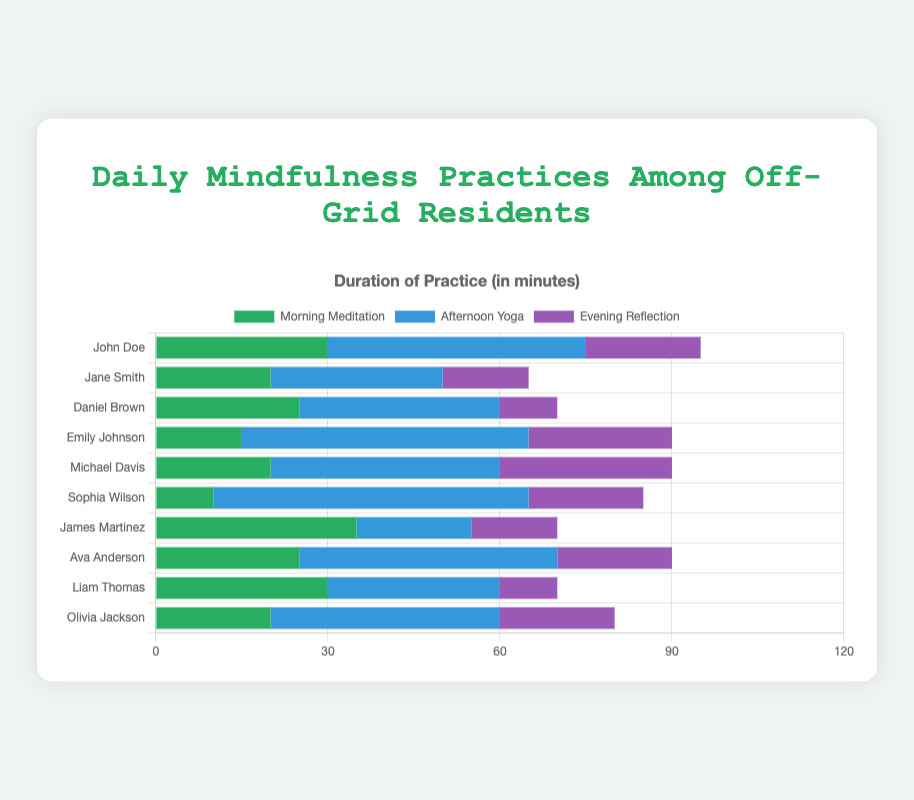Which resident spends the most time on evening reflection? Looking at the “Evening Reflection” segment for each resident, the one with the longest bar is Michael Davis, who spends 30 minutes on evening reflection.
Answer: Michael Davis What is the total duration of mindfulness practices of John Doe? Adding up the different practices for John: Morning Meditation (30 minutes) + Afternoon Yoga (45 minutes) + Evening Reflection (20 minutes) equals 95 minutes.
Answer: 95 minutes Who spends equal or more time on morning meditation than afternoon yoga? Comparing each resident's "Morning Meditation" and "Afternoon Yoga" bars: James Martinez spends equal, and John Doe, Daniel Brown, and Liam Thomas spend more time on morning meditation than on afternoon yoga.
Answer: James Martinez, John Doe, Daniel Brown, Liam Thomas How much more time does Michael Davis spend on afternoon yoga compared to his evening reflection? Michael Davis spends 40 minutes on afternoon yoga and 30 minutes on evening reflection. The difference is 40 - 30 = 10 minutes.
Answer: 10 minutes Which resident has the shortest total duration of mindfulness practices? Summing up the durations for all residents, Sophia Wilson practices for 85 minutes: Morning Meditation (10) + Afternoon Yoga (55) + Evening Reflection (20), which is the smallest sum.
Answer: Sophia Wilson What is the average duration of morning meditation across all residents? Adding up the morning meditation times: 30 + 20 + 25 + 15 + 20 + 10 + 35 + 25 + 30 + 20 = 230 minutes. There are 10 residents, so the average is 230 / 10 = 23 minutes.
Answer: 23 minutes Who spends the most total time on all mindfulness practices combined? Adding up the durations for each resident: the largest sum is for Emily Johnson (15 + 50 + 25 = 90).
Answer: Emily Johnson What is the difference in the duration of afternoon yoga between Jane Smith and Ava Anderson? Jane Smith spends 30 minutes on afternoon yoga and Ava Anderson spends 45 minutes. The difference is 45 - 30 = 15 minutes.
Answer: 15 minutes Which practice has the highest total duration across all residents? Summing up each practice across all residents: Morning Meditation totals 230 minutes, Afternoon Yoga totals 390 minutes, and Evening Reflection totals 185 minutes. The highest is Afternoon Yoga.
Answer: Afternoon Yoga 